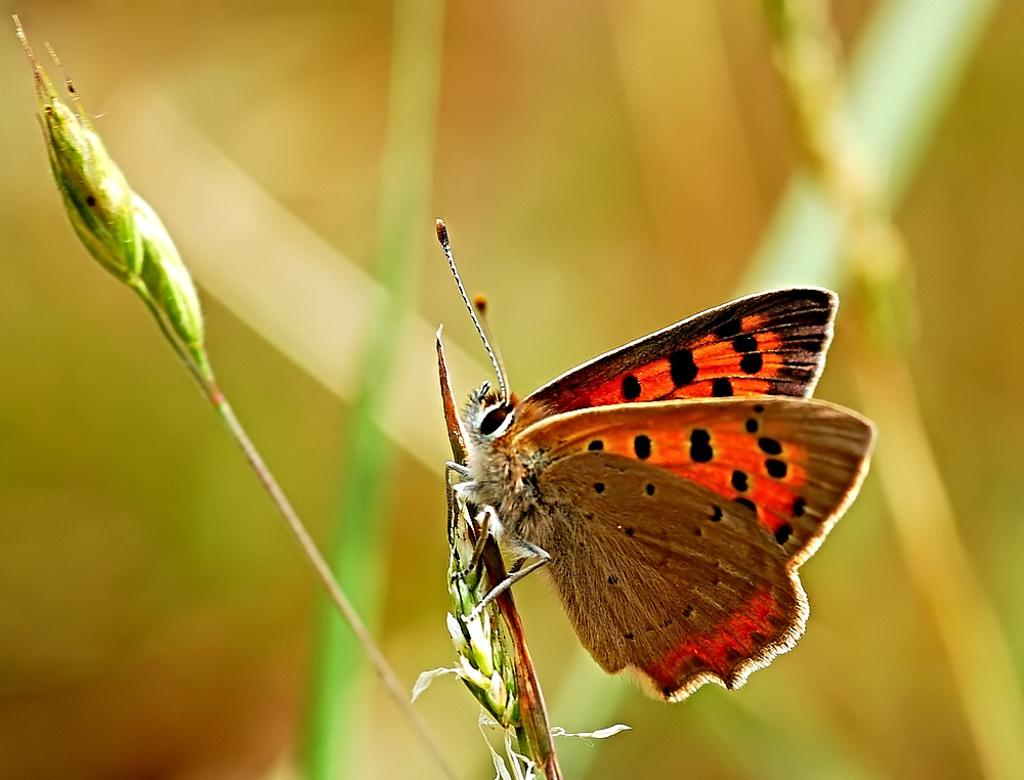What is present in the image that represents new growth? There are buds in the image. Is there any wildlife visible in the image? Yes, there is a butterfly on a bud in the image. How would you describe the overall appearance of the image? The background of the image is blurry. How many babies are present in the image? There are no babies present in the image. What type of work is the pet doing in the image? There is no pet present in the image, so it cannot be performing any work. 